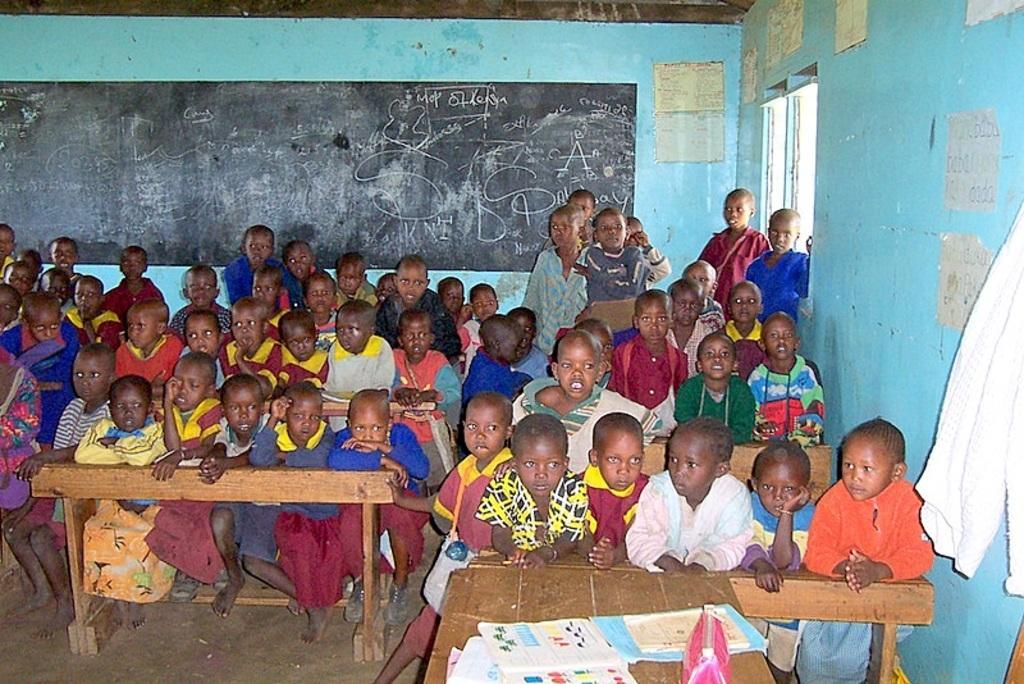In one or two sentences, can you explain what this image depicts? This image is taken inside the classroom where the students are sitting and standing. In the background there is a black board and a wall there are pipes attached to the wall. In the front on the table there are some books and a purse. At the right side there is a white colour cloth hanging and a window. 